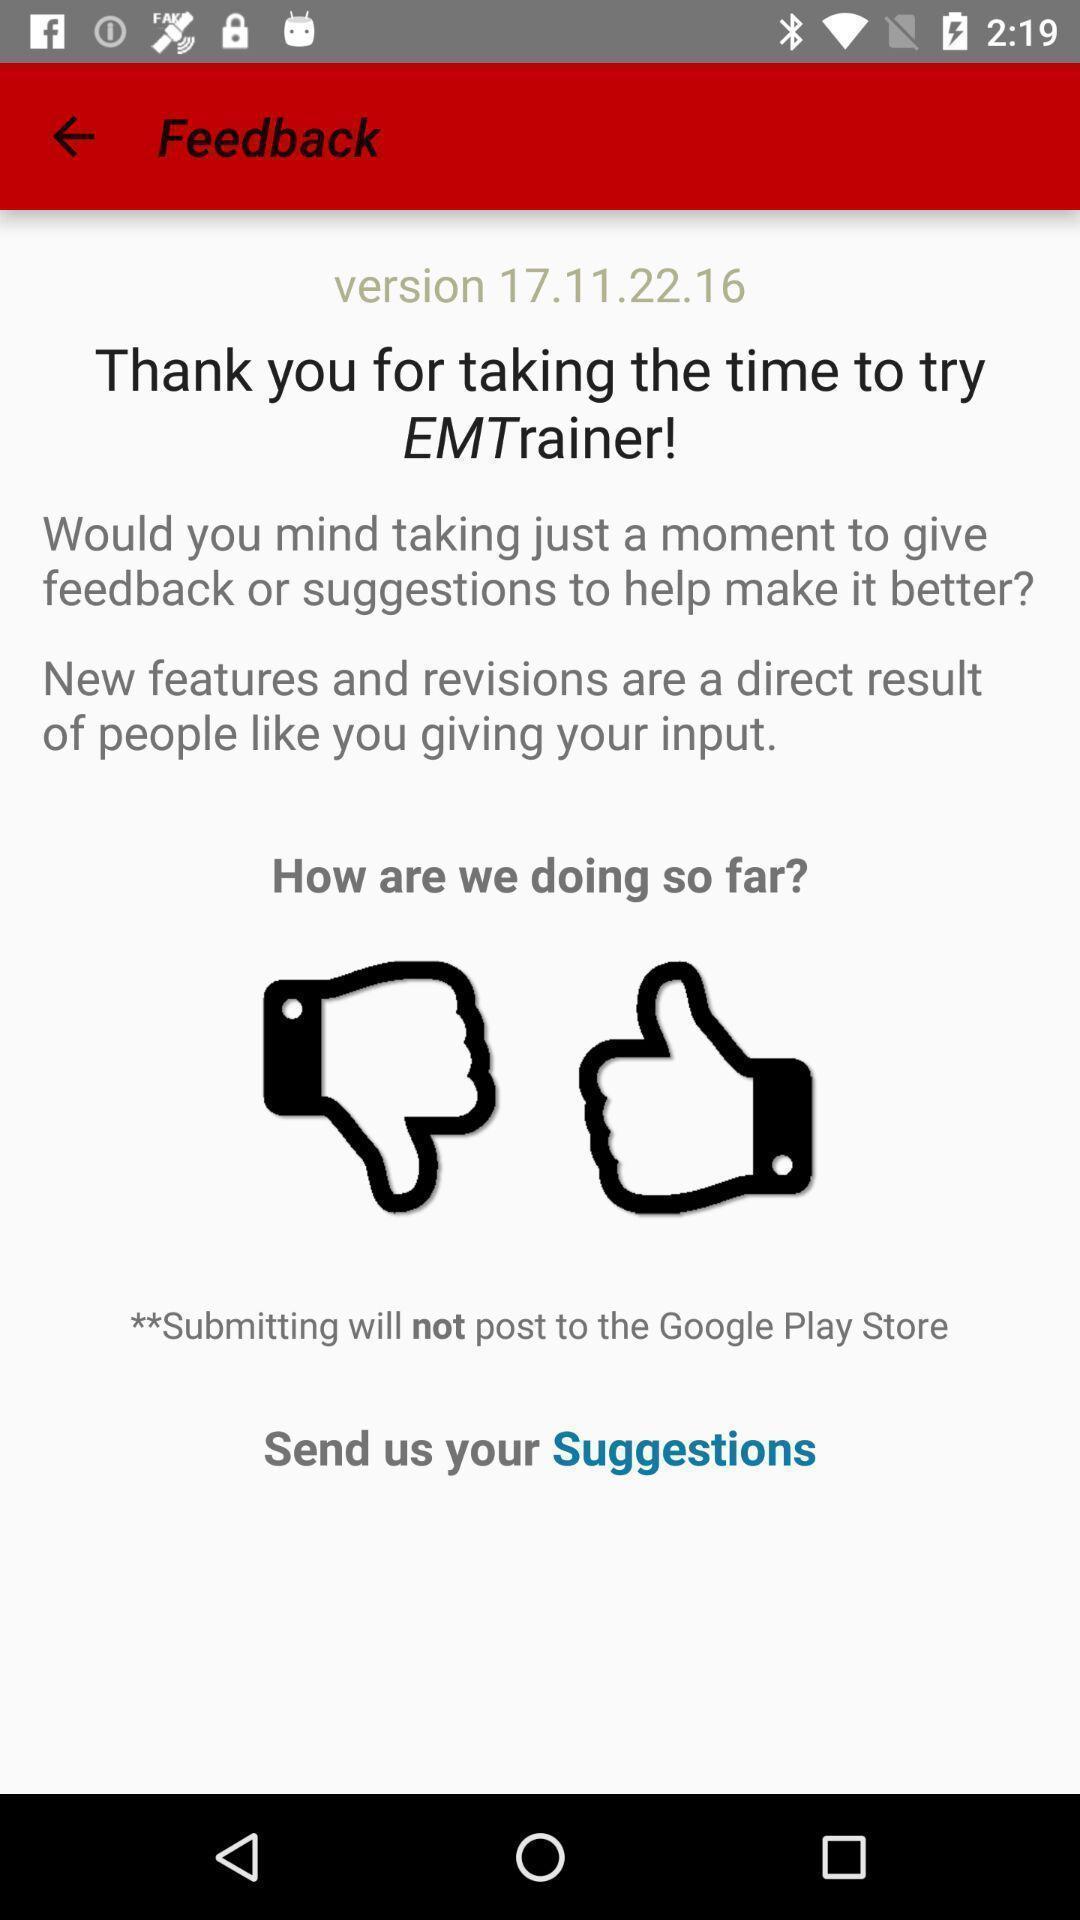What can you discern from this picture? Page showing a rating of feed back. 